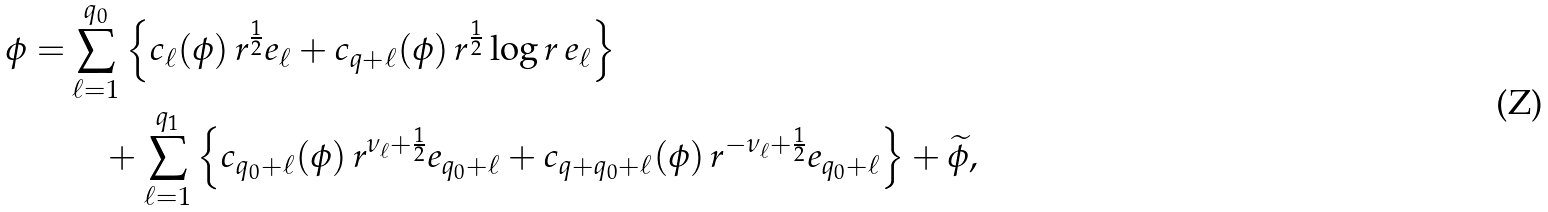<formula> <loc_0><loc_0><loc_500><loc_500>\phi = & \sum _ { \ell = 1 } ^ { q _ { 0 } } \left \{ { c _ { \ell } ( \phi ) } \, r ^ { \frac { 1 } { 2 } } e _ { \ell } + { c _ { q + \ell } ( \phi ) } \, r ^ { \frac { 1 } { 2 } } \log r \, e _ { \ell } \right \} \\ & \quad + \sum _ { \ell = 1 } ^ { q _ { 1 } } \left \{ c _ { q _ { 0 } + \ell } ( \phi ) \, r ^ { \nu _ { \ell } + \frac { 1 } { 2 } } e _ { q _ { 0 } + \ell } + c _ { q + q _ { 0 } + \ell } ( \phi ) \, r ^ { - \nu _ { \ell } + \frac { 1 } { 2 } } e _ { q _ { 0 } + \ell } \right \} + \widetilde { \phi } ,</formula> 